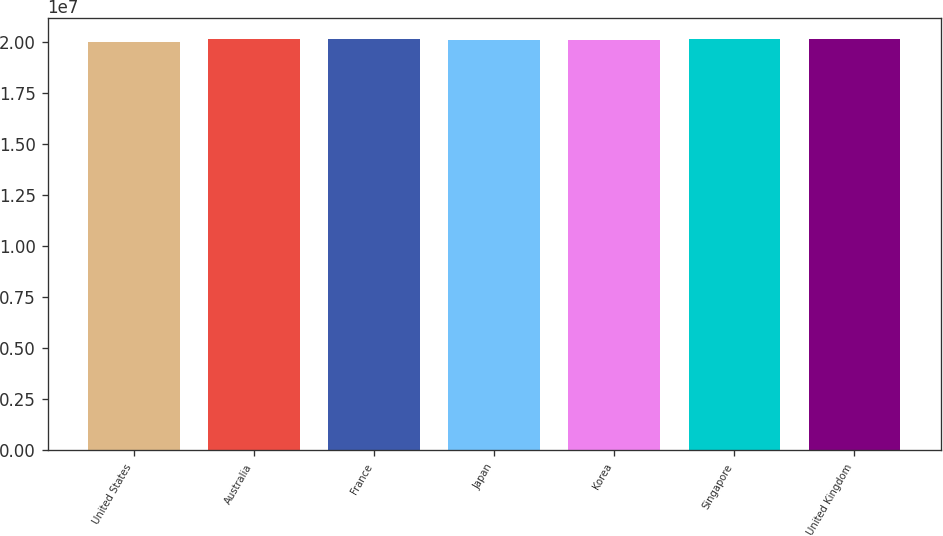<chart> <loc_0><loc_0><loc_500><loc_500><bar_chart><fcel>United States<fcel>Australia<fcel>France<fcel>Japan<fcel>Korea<fcel>Singapore<fcel>United Kingdom<nl><fcel>2.0002e+07<fcel>2.0118e+07<fcel>2.0144e+07<fcel>2.0092e+07<fcel>2.0105e+07<fcel>2.0131e+07<fcel>2.0157e+07<nl></chart> 